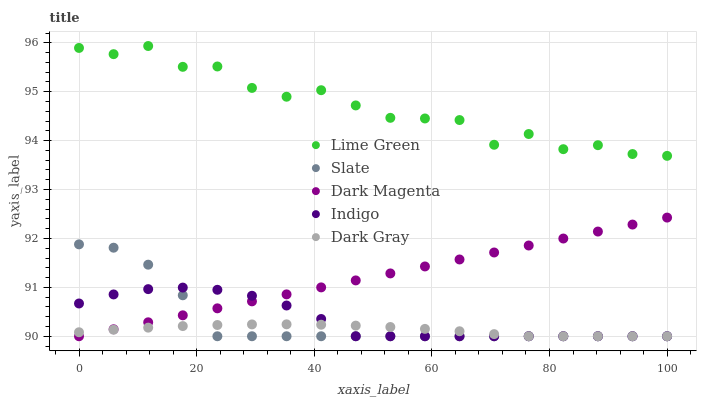Does Dark Gray have the minimum area under the curve?
Answer yes or no. Yes. Does Lime Green have the maximum area under the curve?
Answer yes or no. Yes. Does Indigo have the minimum area under the curve?
Answer yes or no. No. Does Indigo have the maximum area under the curve?
Answer yes or no. No. Is Dark Magenta the smoothest?
Answer yes or no. Yes. Is Lime Green the roughest?
Answer yes or no. Yes. Is Indigo the smoothest?
Answer yes or no. No. Is Indigo the roughest?
Answer yes or no. No. Does Dark Gray have the lowest value?
Answer yes or no. Yes. Does Lime Green have the lowest value?
Answer yes or no. No. Does Lime Green have the highest value?
Answer yes or no. Yes. Does Indigo have the highest value?
Answer yes or no. No. Is Slate less than Lime Green?
Answer yes or no. Yes. Is Lime Green greater than Indigo?
Answer yes or no. Yes. Does Slate intersect Indigo?
Answer yes or no. Yes. Is Slate less than Indigo?
Answer yes or no. No. Is Slate greater than Indigo?
Answer yes or no. No. Does Slate intersect Lime Green?
Answer yes or no. No. 